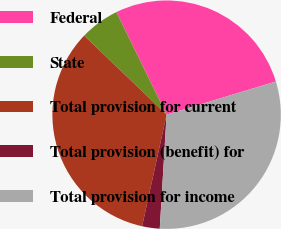Convert chart. <chart><loc_0><loc_0><loc_500><loc_500><pie_chart><fcel>Federal<fcel>State<fcel>Total provision for current<fcel>Total provision (benefit) for<fcel>Total provision for income<nl><fcel>27.55%<fcel>5.59%<fcel>33.72%<fcel>2.49%<fcel>30.65%<nl></chart> 